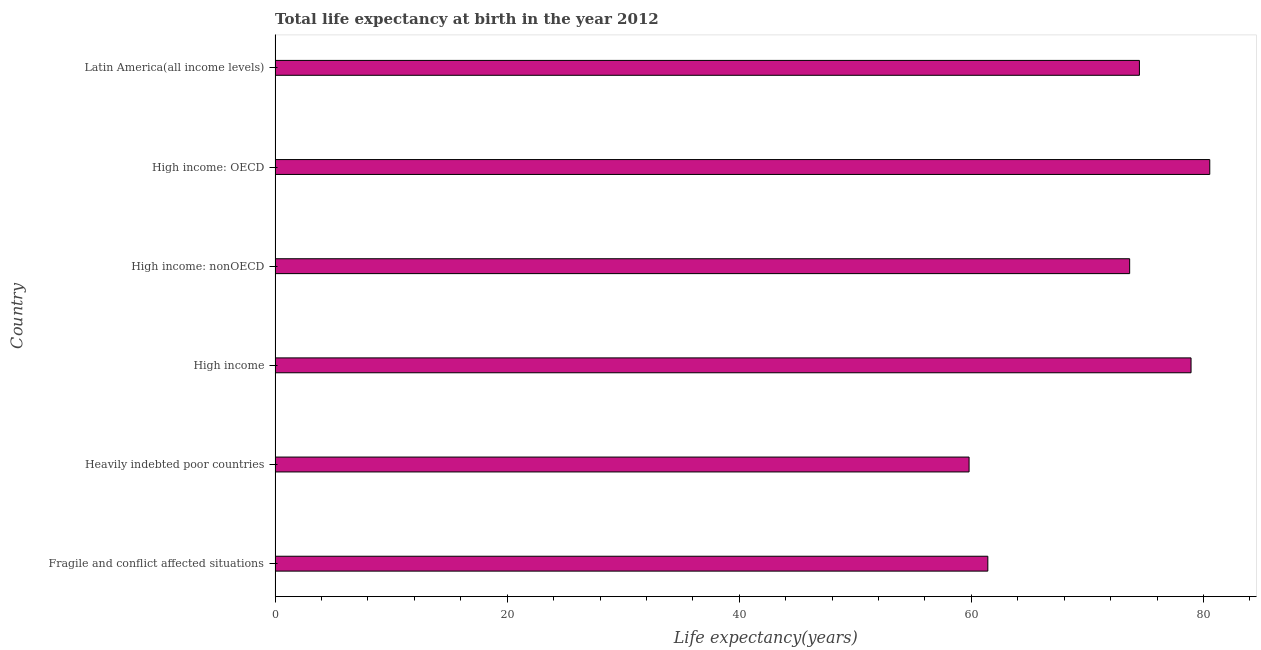Does the graph contain any zero values?
Keep it short and to the point. No. Does the graph contain grids?
Make the answer very short. No. What is the title of the graph?
Your answer should be very brief. Total life expectancy at birth in the year 2012. What is the label or title of the X-axis?
Offer a terse response. Life expectancy(years). What is the label or title of the Y-axis?
Provide a short and direct response. Country. What is the life expectancy at birth in High income: OECD?
Make the answer very short. 80.54. Across all countries, what is the maximum life expectancy at birth?
Provide a short and direct response. 80.54. Across all countries, what is the minimum life expectancy at birth?
Your answer should be compact. 59.8. In which country was the life expectancy at birth maximum?
Make the answer very short. High income: OECD. In which country was the life expectancy at birth minimum?
Ensure brevity in your answer.  Heavily indebted poor countries. What is the sum of the life expectancy at birth?
Offer a terse response. 428.79. What is the difference between the life expectancy at birth in High income and Latin America(all income levels)?
Make the answer very short. 4.45. What is the average life expectancy at birth per country?
Provide a succinct answer. 71.46. What is the median life expectancy at birth?
Ensure brevity in your answer.  74.06. In how many countries, is the life expectancy at birth greater than 56 years?
Give a very brief answer. 6. What is the ratio of the life expectancy at birth in Heavily indebted poor countries to that in High income?
Offer a very short reply. 0.76. What is the difference between the highest and the second highest life expectancy at birth?
Make the answer very short. 1.61. What is the difference between the highest and the lowest life expectancy at birth?
Provide a succinct answer. 20.74. How many bars are there?
Make the answer very short. 6. What is the difference between two consecutive major ticks on the X-axis?
Your answer should be very brief. 20. Are the values on the major ticks of X-axis written in scientific E-notation?
Your response must be concise. No. What is the Life expectancy(years) of Fragile and conflict affected situations?
Provide a succinct answer. 61.41. What is the Life expectancy(years) of Heavily indebted poor countries?
Make the answer very short. 59.8. What is the Life expectancy(years) of High income?
Give a very brief answer. 78.93. What is the Life expectancy(years) in High income: nonOECD?
Offer a very short reply. 73.63. What is the Life expectancy(years) in High income: OECD?
Offer a terse response. 80.54. What is the Life expectancy(years) of Latin America(all income levels)?
Keep it short and to the point. 74.48. What is the difference between the Life expectancy(years) in Fragile and conflict affected situations and Heavily indebted poor countries?
Your response must be concise. 1.62. What is the difference between the Life expectancy(years) in Fragile and conflict affected situations and High income?
Your response must be concise. -17.51. What is the difference between the Life expectancy(years) in Fragile and conflict affected situations and High income: nonOECD?
Offer a very short reply. -12.22. What is the difference between the Life expectancy(years) in Fragile and conflict affected situations and High income: OECD?
Your answer should be compact. -19.12. What is the difference between the Life expectancy(years) in Fragile and conflict affected situations and Latin America(all income levels)?
Your response must be concise. -13.06. What is the difference between the Life expectancy(years) in Heavily indebted poor countries and High income?
Ensure brevity in your answer.  -19.13. What is the difference between the Life expectancy(years) in Heavily indebted poor countries and High income: nonOECD?
Offer a very short reply. -13.84. What is the difference between the Life expectancy(years) in Heavily indebted poor countries and High income: OECD?
Your response must be concise. -20.74. What is the difference between the Life expectancy(years) in Heavily indebted poor countries and Latin America(all income levels)?
Ensure brevity in your answer.  -14.68. What is the difference between the Life expectancy(years) in High income and High income: nonOECD?
Provide a succinct answer. 5.29. What is the difference between the Life expectancy(years) in High income and High income: OECD?
Your answer should be compact. -1.61. What is the difference between the Life expectancy(years) in High income and Latin America(all income levels)?
Offer a very short reply. 4.45. What is the difference between the Life expectancy(years) in High income: nonOECD and High income: OECD?
Offer a terse response. -6.9. What is the difference between the Life expectancy(years) in High income: nonOECD and Latin America(all income levels)?
Your answer should be compact. -0.84. What is the difference between the Life expectancy(years) in High income: OECD and Latin America(all income levels)?
Your answer should be very brief. 6.06. What is the ratio of the Life expectancy(years) in Fragile and conflict affected situations to that in High income?
Your answer should be compact. 0.78. What is the ratio of the Life expectancy(years) in Fragile and conflict affected situations to that in High income: nonOECD?
Make the answer very short. 0.83. What is the ratio of the Life expectancy(years) in Fragile and conflict affected situations to that in High income: OECD?
Your answer should be very brief. 0.76. What is the ratio of the Life expectancy(years) in Fragile and conflict affected situations to that in Latin America(all income levels)?
Make the answer very short. 0.82. What is the ratio of the Life expectancy(years) in Heavily indebted poor countries to that in High income?
Ensure brevity in your answer.  0.76. What is the ratio of the Life expectancy(years) in Heavily indebted poor countries to that in High income: nonOECD?
Provide a succinct answer. 0.81. What is the ratio of the Life expectancy(years) in Heavily indebted poor countries to that in High income: OECD?
Provide a succinct answer. 0.74. What is the ratio of the Life expectancy(years) in Heavily indebted poor countries to that in Latin America(all income levels)?
Your answer should be compact. 0.8. What is the ratio of the Life expectancy(years) in High income to that in High income: nonOECD?
Your answer should be very brief. 1.07. What is the ratio of the Life expectancy(years) in High income to that in High income: OECD?
Your answer should be very brief. 0.98. What is the ratio of the Life expectancy(years) in High income to that in Latin America(all income levels)?
Make the answer very short. 1.06. What is the ratio of the Life expectancy(years) in High income: nonOECD to that in High income: OECD?
Ensure brevity in your answer.  0.91. What is the ratio of the Life expectancy(years) in High income: nonOECD to that in Latin America(all income levels)?
Your response must be concise. 0.99. What is the ratio of the Life expectancy(years) in High income: OECD to that in Latin America(all income levels)?
Give a very brief answer. 1.08. 